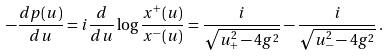Convert formula to latex. <formula><loc_0><loc_0><loc_500><loc_500>- \frac { d p ( u ) } { d u } = i \frac { d } { d u } \log \frac { x ^ { + } ( u ) } { x ^ { - } ( u ) } = \frac { i } { \sqrt { u _ { + } ^ { 2 } - 4 g ^ { 2 } } } - \frac { i } { \sqrt { u _ { - } ^ { 2 } - 4 g ^ { 2 } } } \, .</formula> 